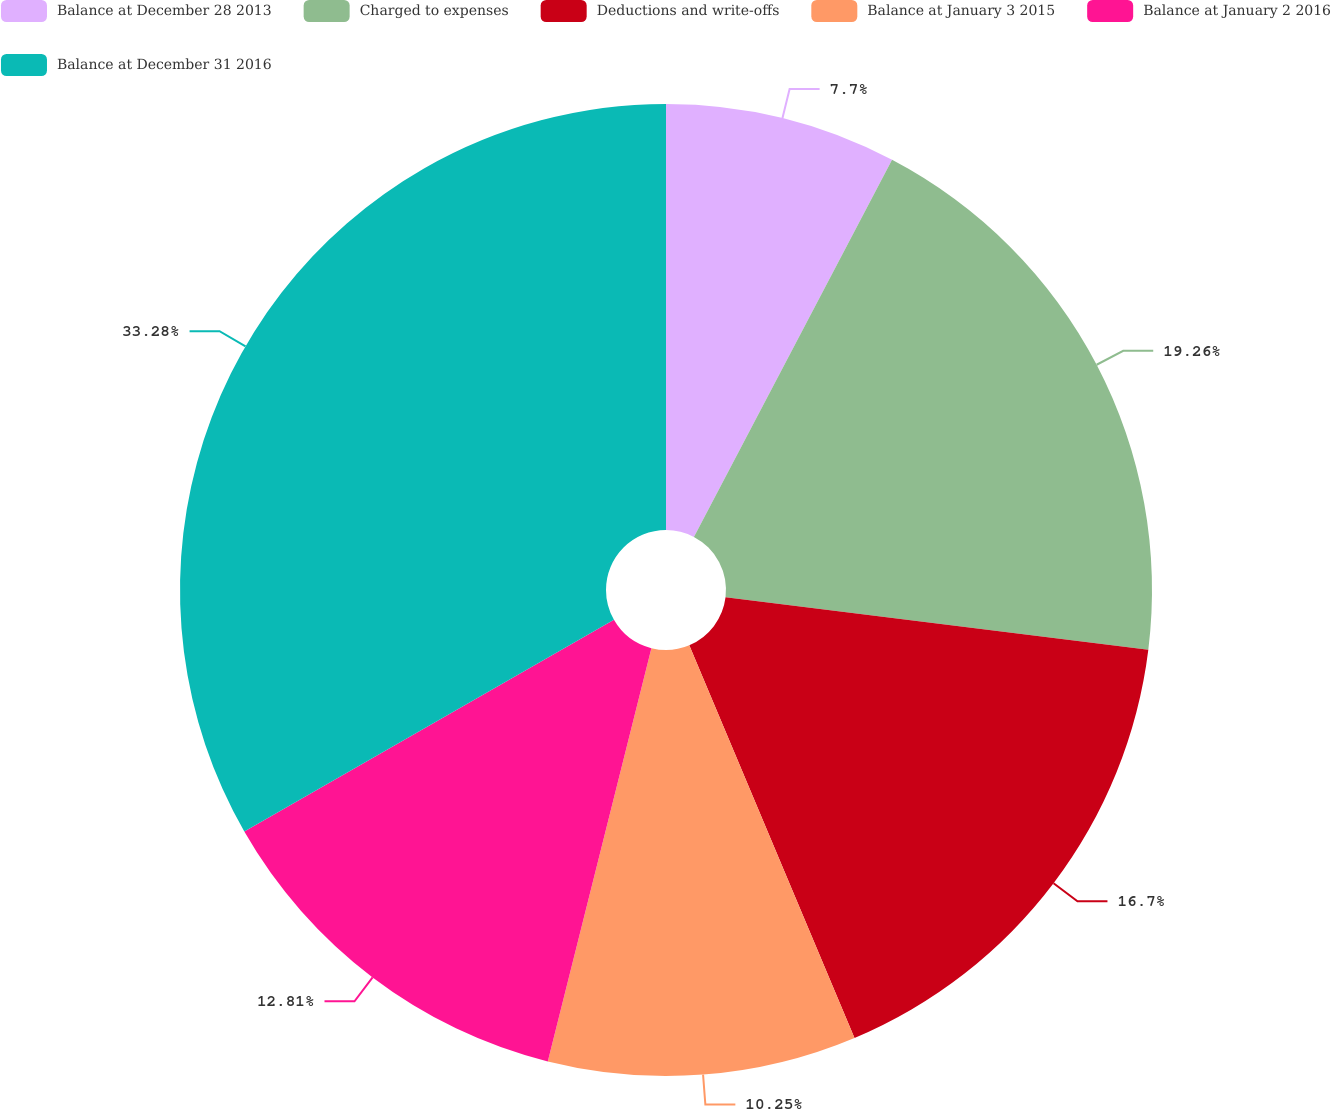Convert chart. <chart><loc_0><loc_0><loc_500><loc_500><pie_chart><fcel>Balance at December 28 2013<fcel>Charged to expenses<fcel>Deductions and write-offs<fcel>Balance at January 3 2015<fcel>Balance at January 2 2016<fcel>Balance at December 31 2016<nl><fcel>7.7%<fcel>19.26%<fcel>16.7%<fcel>10.25%<fcel>12.81%<fcel>33.28%<nl></chart> 